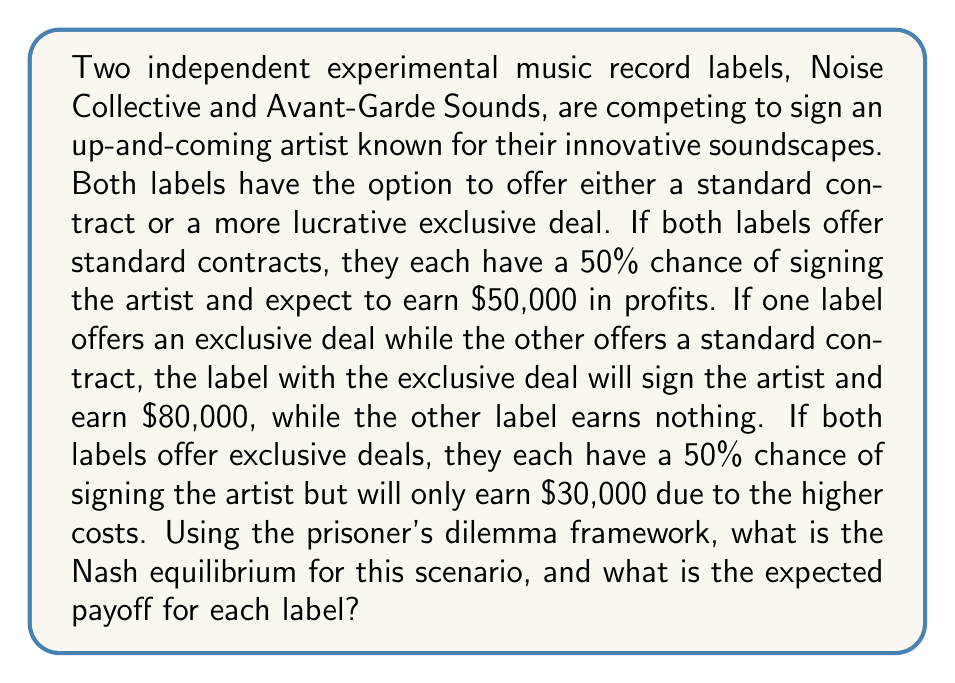Can you solve this math problem? To solve this problem, we need to follow these steps:

1. Set up the payoff matrix for the prisoner's dilemma scenario.
2. Identify the dominant strategy for each label.
3. Determine the Nash equilibrium.
4. Calculate the expected payoff for each label.

Step 1: Payoff Matrix

Let's create a payoff matrix for this scenario:

[asy]
unitsize(1cm);

draw((0,0)--(6,0)--(6,4)--(0,4)--cycle);
draw((0,2)--(6,2));
draw((3,0)--(3,4));

label("Noise Collective", (1.5,3.5));
label("Standard", (1.5,2.5));
label("Exclusive", (1.5,0.5));

label("Avant-Garde Sounds", (4.5,3.5));
label("Standard", (3.5,3));
label("Exclusive", (5.5,3));

label("(50k, 50k)", (2.25,2.25));
label("(0, 80k)", (2.25,0.75));
label("(80k, 0)", (4.75,2.25));
label("(30k, 30k)", (4.75,0.75));
[/asy]

Step 2: Dominant Strategy

For Noise Collective:
- If Avant-Garde offers Standard: Exclusive (80k) > Standard (50k)
- If Avant-Garde offers Exclusive: Exclusive (30k) > Standard (0)

For Avant-Garde Sounds:
- If Noise Collective offers Standard: Exclusive (80k) > Standard (50k)
- If Noise Collective offers Exclusive: Exclusive (30k) > Standard (0)

The dominant strategy for both labels is to offer an Exclusive deal.

Step 3: Nash Equilibrium

The Nash equilibrium occurs when both labels offer Exclusive deals, as neither label can unilaterally improve their position by changing their strategy.

Step 4: Expected Payoff

At the Nash equilibrium (both offering Exclusive deals), each label has a 50% chance of signing the artist and earning $30,000. Therefore, the expected payoff for each label is:

$$ \text{Expected Payoff} = 0.5 \times \$30,000 = \$15,000 $$
Answer: The Nash equilibrium is for both labels to offer Exclusive deals, and the expected payoff for each label is $15,000. 